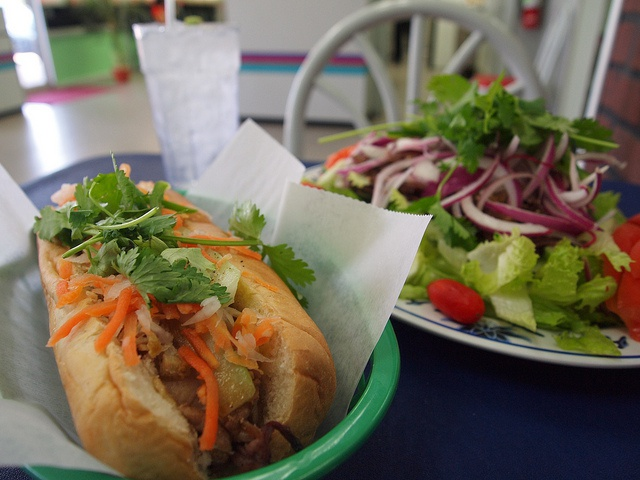Describe the objects in this image and their specific colors. I can see sandwich in white, olive, brown, maroon, and tan tones, dining table in white, black, and gray tones, chair in white, gray, darkgray, and black tones, bowl in white, black, darkgreen, and darkgray tones, and cup in white, lightgray, and darkgray tones in this image. 